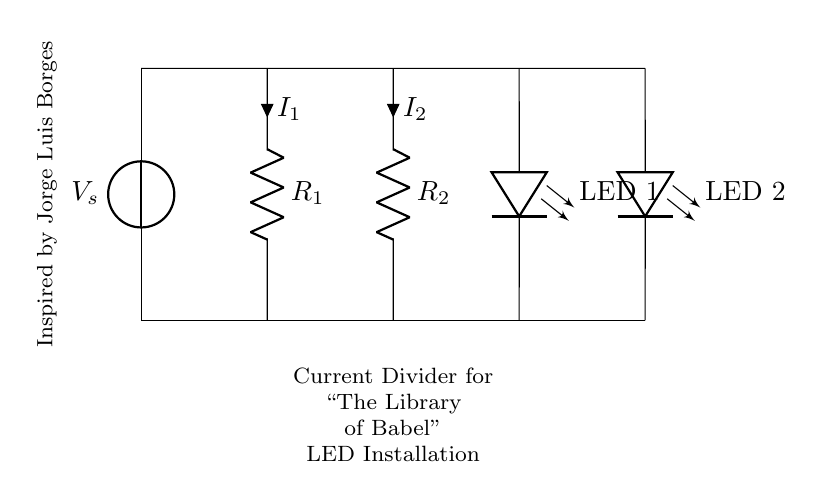What is the source voltage in the circuit? The source voltage is indicated at the top left of the diagram where V_s is labeled. It represents the applied voltage across the circuit.
Answer: V_s What are the resistances in the circuit? The circuit diagram shows two resistors labeled as R_1 and R_2. These are the parameters that determine how the current divides between them.
Answer: R_1, R_2 How many LEDs are present in the circuit? The circuit diagram displays two LED components labeled as LED 1 and LED 2, indicating the number of LEDs used in this installation.
Answer: 2 What is the total current passing through the circuit? The total current can be determined by observing how the currents I_1 and I_2 are divided between the two resistors, but the total current is not specified in the diagram itself. Assuming a typical application, it would depend on the values of R_1 and R_2.
Answer: Not specified How does the current split between R_1 and R_2? In a current divider, the total current entering the junction splits between the branches inversely proportional to their resistances; thus, the lower the resistance, the higher the current through that branch. Understanding Ohm's law establishes this relationship.
Answer: Inversely proportional What inspires the design of the circuit? The circuit layout is directly inspired by Jorge Luis Borges, specifically his concept of "The Library of Babel," indicating a thematic connection between art and science in the installation.
Answer: Borges 